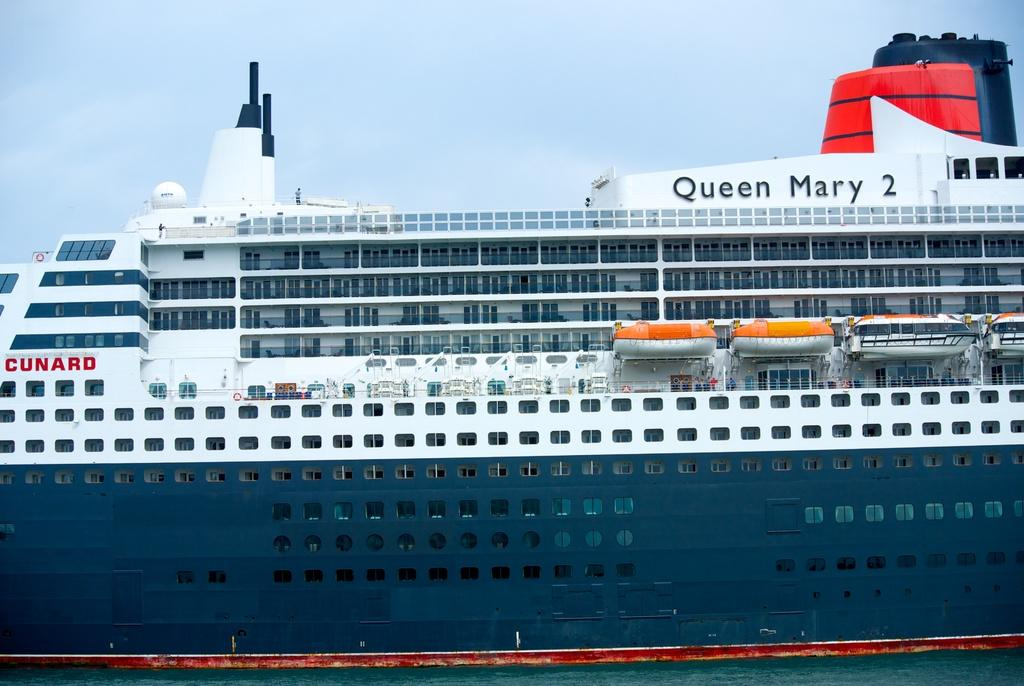What is the main subject of the image? The main subject of the image is a cruise. Where is the cruise located? The cruise is on the ocean. What can be seen on the cruise? There is text on the cruise. What is visible at the top of the image? The sky is visible at the top of the image. Are there any police officers or tanks visible in the image? No, there are no police officers or tanks present in the image. Is there any crime being committed on the cruise in the image? There is no indication of any crime being committed in the image, as it primarily features a cruise on the ocean. 